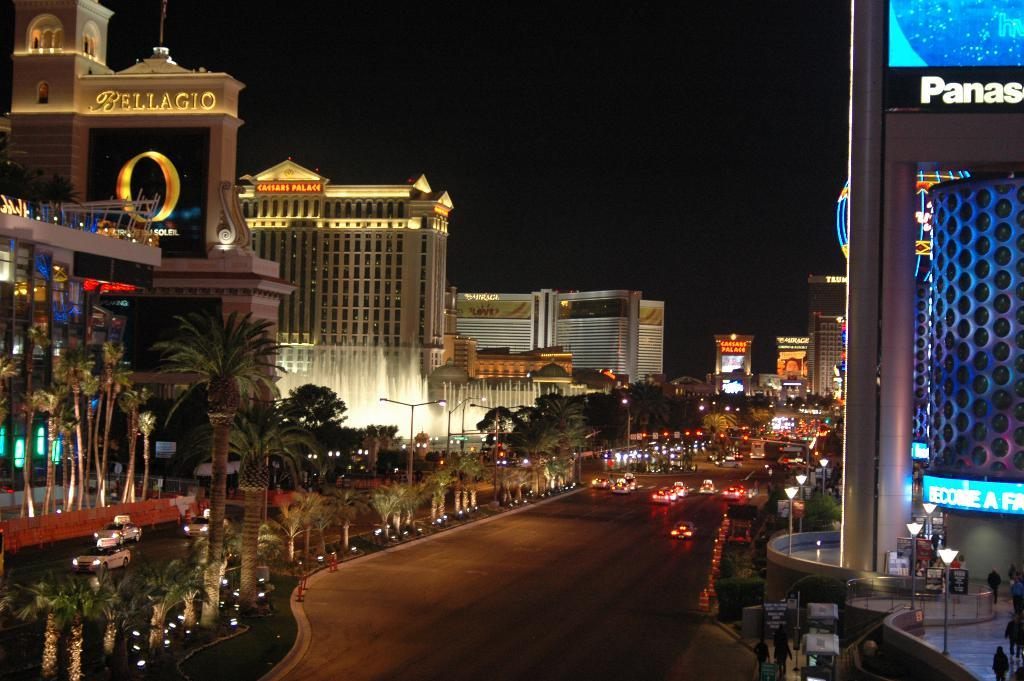<image>
Relay a brief, clear account of the picture shown. The Bellagio has a big golden O on it. 